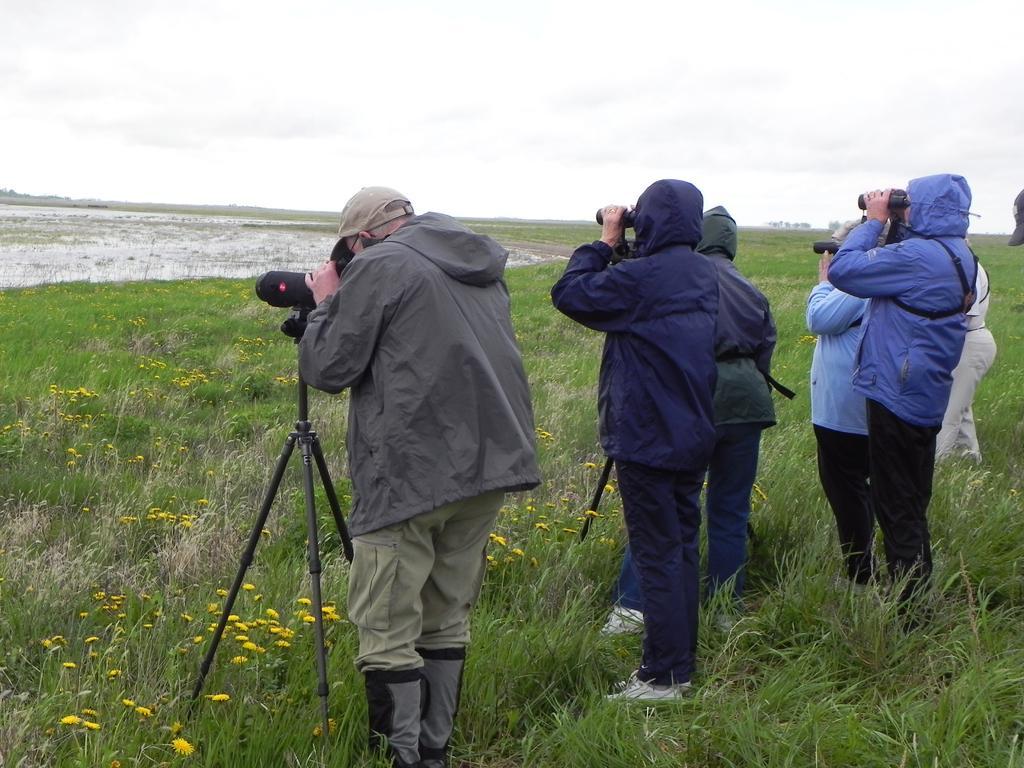Can you describe this image briefly? In this image we can see the people standing and holding the binoculars. We can also see the stands, grass, flowers and also the sky. 